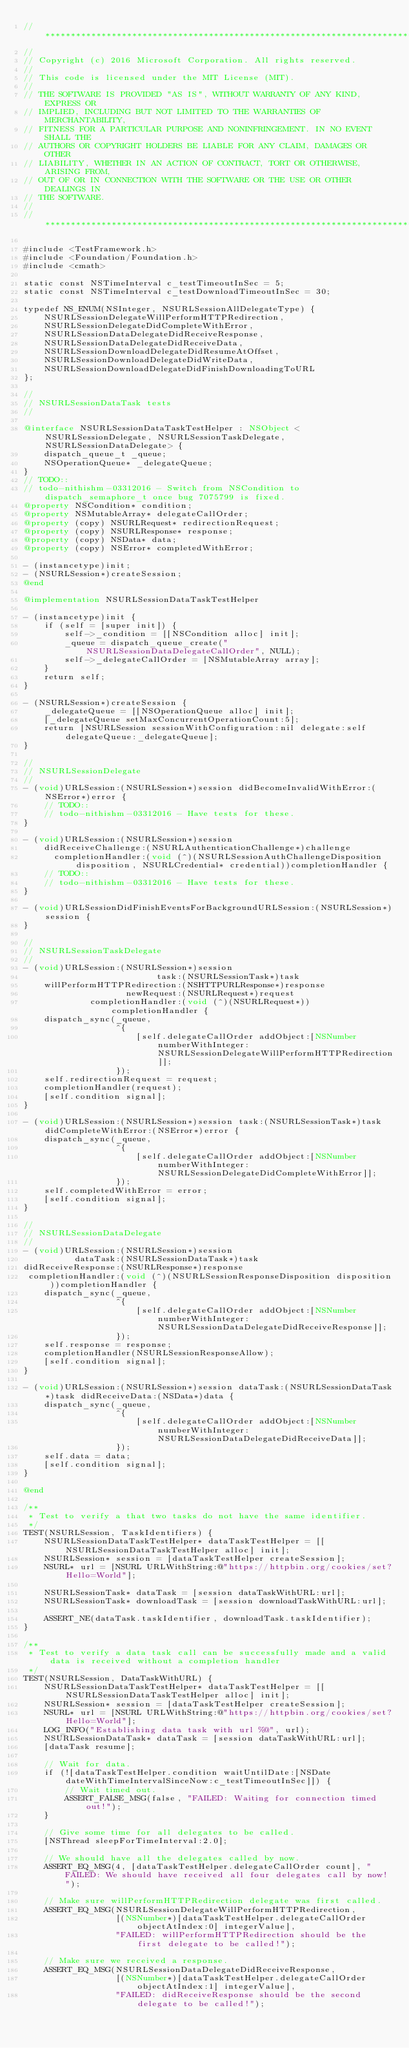Convert code to text. <code><loc_0><loc_0><loc_500><loc_500><_ObjectiveC_>//******************************************************************************
//
// Copyright (c) 2016 Microsoft Corporation. All rights reserved.
//
// This code is licensed under the MIT License (MIT).
//
// THE SOFTWARE IS PROVIDED "AS IS", WITHOUT WARRANTY OF ANY KIND, EXPRESS OR
// IMPLIED, INCLUDING BUT NOT LIMITED TO THE WARRANTIES OF MERCHANTABILITY,
// FITNESS FOR A PARTICULAR PURPOSE AND NONINFRINGEMENT. IN NO EVENT SHALL THE
// AUTHORS OR COPYRIGHT HOLDERS BE LIABLE FOR ANY CLAIM, DAMAGES OR OTHER
// LIABILITY, WHETHER IN AN ACTION OF CONTRACT, TORT OR OTHERWISE, ARISING FROM,
// OUT OF OR IN CONNECTION WITH THE SOFTWARE OR THE USE OR OTHER DEALINGS IN
// THE SOFTWARE.
//
//******************************************************************************

#include <TestFramework.h>
#include <Foundation/Foundation.h>
#include <cmath>

static const NSTimeInterval c_testTimeoutInSec = 5;
static const NSTimeInterval c_testDownloadTimeoutInSec = 30;

typedef NS_ENUM(NSInteger, NSURLSessionAllDelegateType) {
    NSURLSessionDelegateWillPerformHTTPRedirection,
    NSURLSessionDelegateDidCompleteWithError,
    NSURLSessionDataDelegateDidReceiveResponse,
    NSURLSessionDataDelegateDidReceiveData,
    NSURLSessionDownloadDelegateDidResumeAtOffset,
    NSURLSessionDownloadDelegateDidWriteData,
    NSURLSessionDownloadDelegateDidFinishDownloadingToURL
};

//
// NSURLSessionDataTask tests
//

@interface NSURLSessionDataTaskTestHelper : NSObject <NSURLSessionDelegate, NSURLSessionTaskDelegate, NSURLSessionDataDelegate> {
    dispatch_queue_t _queue;
    NSOperationQueue* _delegateQueue;
}
// TODO::
// todo-nithishm-03312016 - Switch from NSCondition to dispatch_semaphore_t once bug 7075799 is fixed.
@property NSCondition* condition;
@property NSMutableArray* delegateCallOrder;
@property (copy) NSURLRequest* redirectionRequest;
@property (copy) NSURLResponse* response;
@property (copy) NSData* data;
@property (copy) NSError* completedWithError;

- (instancetype)init;
- (NSURLSession*)createSession;
@end

@implementation NSURLSessionDataTaskTestHelper

- (instancetype)init {
    if (self = [super init]) {
        self->_condition = [[NSCondition alloc] init];
        _queue = dispatch_queue_create("NSURLSessionDataDelegateCallOrder", NULL);
        self->_delegateCallOrder = [NSMutableArray array];
    }
    return self;
}

- (NSURLSession*)createSession {
    _delegateQueue = [[NSOperationQueue alloc] init];
    [_delegateQueue setMaxConcurrentOperationCount:5];
    return [NSURLSession sessionWithConfiguration:nil delegate:self delegateQueue:_delegateQueue];
}

//
// NSURLSessionDelegate
//
- (void)URLSession:(NSURLSession*)session didBecomeInvalidWithError:(NSError*)error {
    // TODO::
    // todo-nithishm-03312016 - Have tests for these.
}

- (void)URLSession:(NSURLSession*)session
    didReceiveChallenge:(NSURLAuthenticationChallenge*)challenge
      completionHandler:(void (^)(NSURLSessionAuthChallengeDisposition disposition, NSURLCredential* credential))completionHandler {
    // TODO::
    // todo-nithishm-03312016 - Have tests for these.
}

- (void)URLSessionDidFinishEventsForBackgroundURLSession:(NSURLSession*)session {
}

//
// NSURLSessionTaskDelegate
//
- (void)URLSession:(NSURLSession*)session
                          task:(NSURLSessionTask*)task
    willPerformHTTPRedirection:(NSHTTPURLResponse*)response
                    newRequest:(NSURLRequest*)request
             completionHandler:(void (^)(NSURLRequest*))completionHandler {
    dispatch_sync(_queue,
                  ^{
                      [self.delegateCallOrder addObject:[NSNumber numberWithInteger:NSURLSessionDelegateWillPerformHTTPRedirection]];
                  });
    self.redirectionRequest = request;
    completionHandler(request);
    [self.condition signal];
}

- (void)URLSession:(NSURLSession*)session task:(NSURLSessionTask*)task didCompleteWithError:(NSError*)error {
    dispatch_sync(_queue,
                  ^{
                      [self.delegateCallOrder addObject:[NSNumber numberWithInteger:NSURLSessionDelegateDidCompleteWithError]];
                  });
    self.completedWithError = error;
    [self.condition signal];
}

//
// NSURLSessionDataDelegate
//
- (void)URLSession:(NSURLSession*)session
          dataTask:(NSURLSessionDataTask*)task
didReceiveResponse:(NSURLResponse*)response
 completionHandler:(void (^)(NSURLSessionResponseDisposition disposition))completionHandler {
    dispatch_sync(_queue,
                  ^{
                      [self.delegateCallOrder addObject:[NSNumber numberWithInteger:NSURLSessionDataDelegateDidReceiveResponse]];
                  });
    self.response = response;
    completionHandler(NSURLSessionResponseAllow);
    [self.condition signal];
}

- (void)URLSession:(NSURLSession*)session dataTask:(NSURLSessionDataTask*)task didReceiveData:(NSData*)data {
    dispatch_sync(_queue,
                  ^{
                      [self.delegateCallOrder addObject:[NSNumber numberWithInteger:NSURLSessionDataDelegateDidReceiveData]];
                  });
    self.data = data;
    [self.condition signal];
}

@end

/**
 * Test to verify a that two tasks do not have the same identifier.
 */
TEST(NSURLSession, TaskIdentifiers) {
    NSURLSessionDataTaskTestHelper* dataTaskTestHelper = [[NSURLSessionDataTaskTestHelper alloc] init];
    NSURLSession* session = [dataTaskTestHelper createSession];
    NSURL* url = [NSURL URLWithString:@"https://httpbin.org/cookies/set?Hello=World"];

    NSURLSessionTask* dataTask = [session dataTaskWithURL:url];
    NSURLSessionTask* downloadTask = [session downloadTaskWithURL:url];

    ASSERT_NE(dataTask.taskIdentifier, downloadTask.taskIdentifier);
}

/**
 * Test to verify a data task call can be successfully made and a valid data is received without a completion handler
 */
TEST(NSURLSession, DataTaskWithURL) {
    NSURLSessionDataTaskTestHelper* dataTaskTestHelper = [[NSURLSessionDataTaskTestHelper alloc] init];
    NSURLSession* session = [dataTaskTestHelper createSession];
    NSURL* url = [NSURL URLWithString:@"https://httpbin.org/cookies/set?Hello=World"];
    LOG_INFO("Establishing data task with url %@", url);
    NSURLSessionDataTask* dataTask = [session dataTaskWithURL:url];
    [dataTask resume];

    // Wait for data.
    if (![dataTaskTestHelper.condition waitUntilDate:[NSDate dateWithTimeIntervalSinceNow:c_testTimeoutInSec]]) {
        // Wait timed out.
        ASSERT_FALSE_MSG(false, "FAILED: Waiting for connection timed out!");
    }

    // Give some time for all delegates to be called.
    [NSThread sleepForTimeInterval:2.0];

    // We should have all the delegates called by now.
    ASSERT_EQ_MSG(4, [dataTaskTestHelper.delegateCallOrder count], "FAILED: We should have received all four delegates call by now!");

    // Make sure willPerformHTTPRedirection delegate was first called.
    ASSERT_EQ_MSG(NSURLSessionDelegateWillPerformHTTPRedirection,
                  [(NSNumber*)[dataTaskTestHelper.delegateCallOrder objectAtIndex:0] integerValue],
                  "FAILED: willPerformHTTPRedirection should be the first delegate to be called!");

    // Make sure we received a response.
    ASSERT_EQ_MSG(NSURLSessionDataDelegateDidReceiveResponse,
                  [(NSNumber*)[dataTaskTestHelper.delegateCallOrder objectAtIndex:1] integerValue],
                  "FAILED: didReceiveResponse should be the second delegate to be called!");</code> 